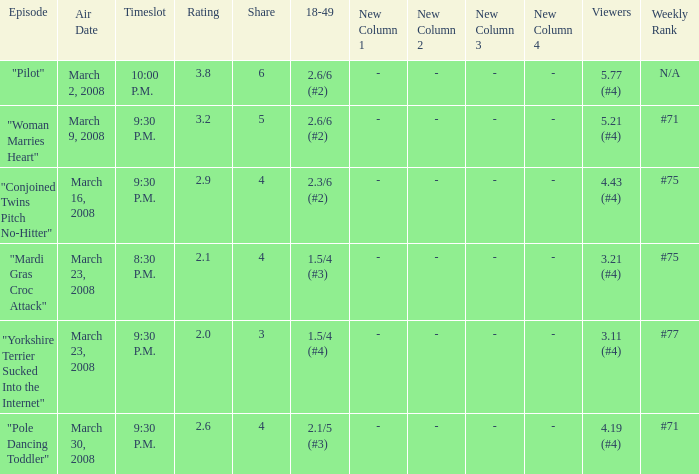What is the total ratings on share less than 4? 1.0. Would you mind parsing the complete table? {'header': ['Episode', 'Air Date', 'Timeslot', 'Rating', 'Share', '18-49', 'New Column 1', 'New Column 2', 'New Column 3', 'New Column 4', 'Viewers', 'Weekly Rank'], 'rows': [['"Pilot"', 'March 2, 2008', '10:00 P.M.', '3.8', '6', '2.6/6 (#2)', '-', '-', '-', '-', '5.77 (#4)', 'N/A'], ['"Woman Marries Heart"', 'March 9, 2008', '9:30 P.M.', '3.2', '5', '2.6/6 (#2)', '-', '-', '-', '-', '5.21 (#4)', '#71'], ['"Conjoined Twins Pitch No-Hitter"', 'March 16, 2008', '9:30 P.M.', '2.9', '4', '2.3/6 (#2)', '-', '-', '-', '-', '4.43 (#4)', '#75'], ['"Mardi Gras Croc Attack"', 'March 23, 2008', '8:30 P.M.', '2.1', '4', '1.5/4 (#3)', '-', '-', '-', '-', '3.21 (#4)', '#75'], ['"Yorkshire Terrier Sucked Into the Internet"', 'March 23, 2008', '9:30 P.M.', '2.0', '3', '1.5/4 (#4)', '-', '-', '-', '-', '3.11 (#4)', '#77'], ['"Pole Dancing Toddler"', 'March 30, 2008', '9:30 P.M.', '2.6', '4', '2.1/5 (#3)', '-', '-', '-', '-', '4.19 (#4)', '#71']]} 